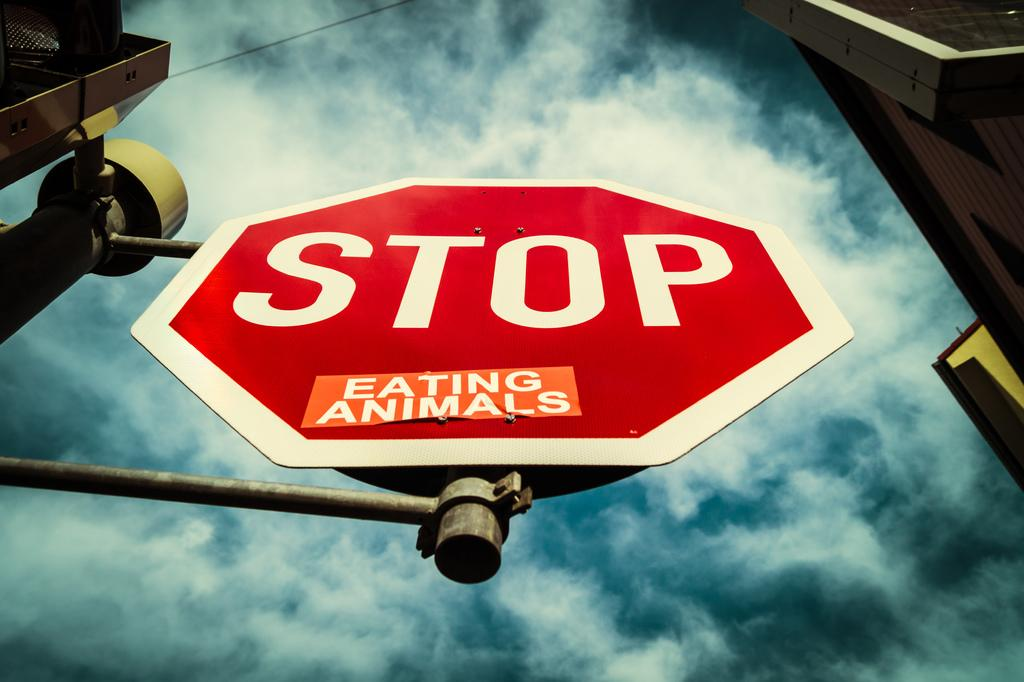<image>
Summarize the visual content of the image. A Stop sign on an extended pole with an "eating animals" sticker added to it 